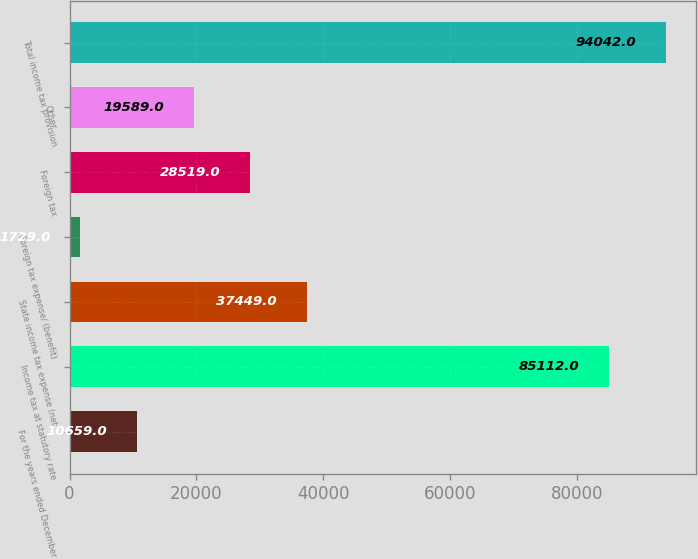Convert chart to OTSL. <chart><loc_0><loc_0><loc_500><loc_500><bar_chart><fcel>For the years ended December<fcel>Income tax at statutory rate<fcel>State income tax expense (net<fcel>Foreign tax expense/ (benefit)<fcel>Foreign tax<fcel>Other<fcel>Total income tax provision<nl><fcel>10659<fcel>85112<fcel>37449<fcel>1729<fcel>28519<fcel>19589<fcel>94042<nl></chart> 